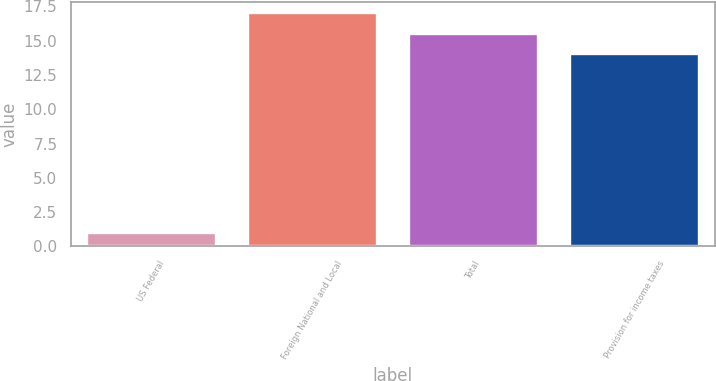Convert chart. <chart><loc_0><loc_0><loc_500><loc_500><bar_chart><fcel>US Federal<fcel>Foreign National and Local<fcel>Total<fcel>Provision for income taxes<nl><fcel>1<fcel>17<fcel>15.5<fcel>14<nl></chart> 